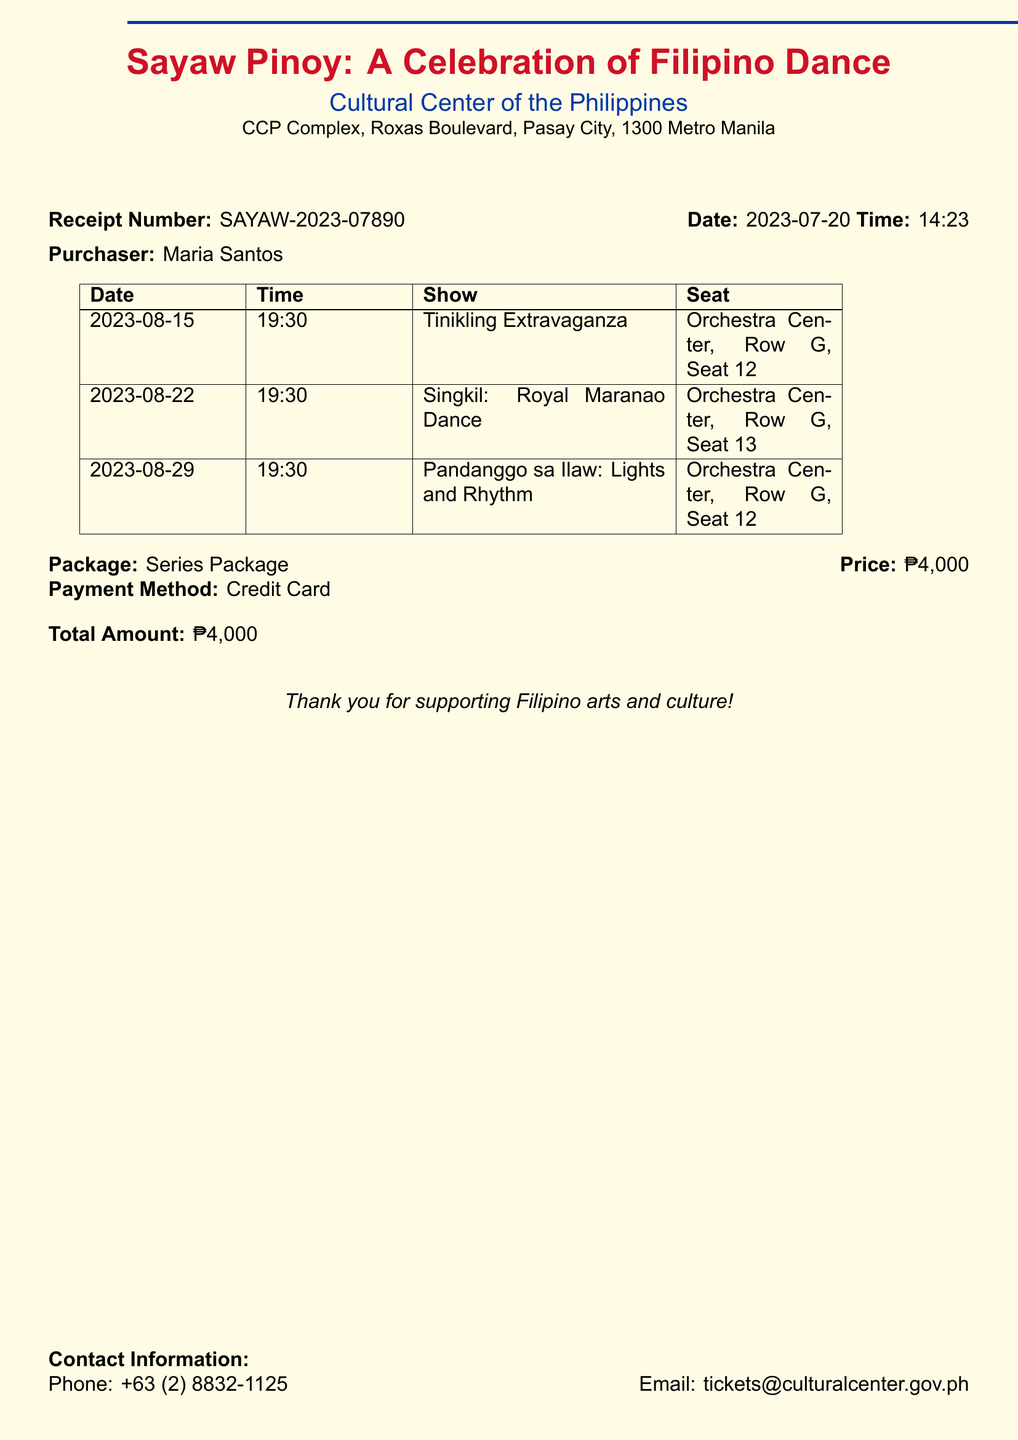What is the receipt number? The receipt number is a unique identifier for the ticket purchase given in the document.
Answer: SAYAW-2023-07890 Who is the purchaser? The purchaser's name is mentioned at the top of the document as the buyer of the tickets.
Answer: Maria Santos What is the date of the first performance? The document lists the performance dates in a table; the first date is noted at the top.
Answer: 2023-08-15 How many performances are included in the series package? The table lists three performances, indicating the number included in the purchase.
Answer: Three What is the price of the series package? The document specifies the total cost for the series package at the bottom.
Answer: ₱4,000 What seat is reserved for the second performance? The seat location for each performance is detailed in the table corresponding to each date.
Answer: Orchestra Center, Row G, Seat 13 What show is scheduled for August 29? The shows are listed alongside their respective dates in the table.
Answer: Pandanggo sa Ilaw: Lights and Rhythm What payment method was used for the purchase? The document states the method used for payment in its specified section.
Answer: Credit Card What is the contact email provided in the document? The contact information at the bottom includes the email for inquiries regarding ticket purchases.
Answer: tickets@culturalcenter.gov.ph 